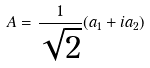<formula> <loc_0><loc_0><loc_500><loc_500>A = \frac { 1 } { \sqrt { 2 } } ( a _ { 1 } + i a _ { 2 } )</formula> 